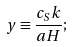<formula> <loc_0><loc_0><loc_500><loc_500>y \equiv \frac { c _ { S } k } { a H } ;</formula> 